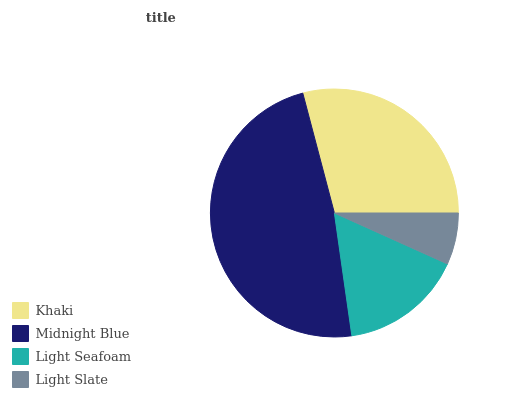Is Light Slate the minimum?
Answer yes or no. Yes. Is Midnight Blue the maximum?
Answer yes or no. Yes. Is Light Seafoam the minimum?
Answer yes or no. No. Is Light Seafoam the maximum?
Answer yes or no. No. Is Midnight Blue greater than Light Seafoam?
Answer yes or no. Yes. Is Light Seafoam less than Midnight Blue?
Answer yes or no. Yes. Is Light Seafoam greater than Midnight Blue?
Answer yes or no. No. Is Midnight Blue less than Light Seafoam?
Answer yes or no. No. Is Khaki the high median?
Answer yes or no. Yes. Is Light Seafoam the low median?
Answer yes or no. Yes. Is Light Slate the high median?
Answer yes or no. No. Is Light Slate the low median?
Answer yes or no. No. 